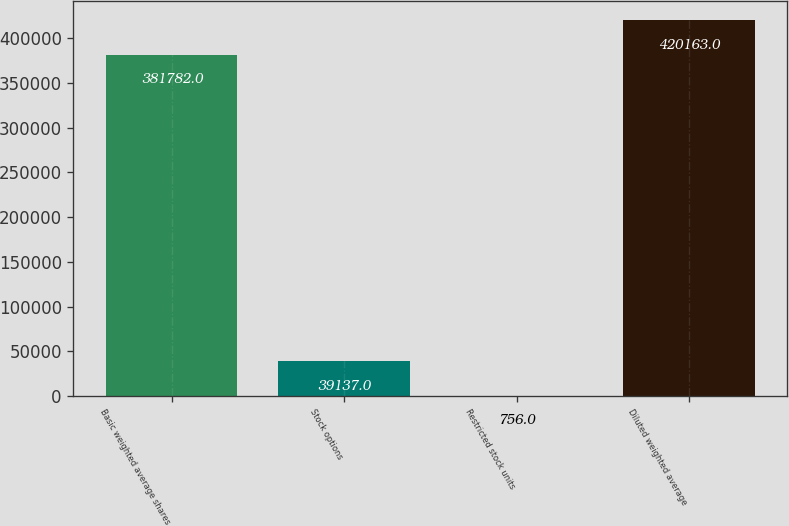Convert chart to OTSL. <chart><loc_0><loc_0><loc_500><loc_500><bar_chart><fcel>Basic weighted average shares<fcel>Stock options<fcel>Restricted stock units<fcel>Diluted weighted average<nl><fcel>381782<fcel>39137<fcel>756<fcel>420163<nl></chart> 